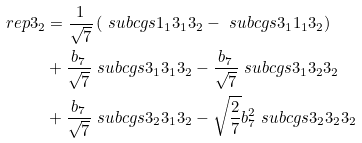<formula> <loc_0><loc_0><loc_500><loc_500>\ r e p { 3 } _ { 2 } & = \frac { 1 } { \sqrt { 7 } } \left ( \ s u b c g s { 1 _ { 1 } } { 3 _ { 1 } } { 3 _ { 2 } } - \ s u b c g s { 3 _ { 1 } } { 1 _ { 1 } } { 3 _ { 2 } } \right ) \\ & + \frac { b _ { 7 } } { \sqrt { 7 } } \ s u b c g s { 3 _ { 1 } } { 3 _ { 1 } } { 3 _ { 2 } } - \frac { b _ { 7 } } { \sqrt { 7 } } \ s u b c g s { 3 _ { 1 } } { 3 _ { 2 } } { 3 _ { 2 } } \\ & + \frac { b _ { 7 } } { \sqrt { 7 } } \ s u b c g s { 3 _ { 2 } } { 3 _ { 1 } } { 3 _ { 2 } } - \sqrt { \frac { 2 } { 7 } } b _ { 7 } ^ { 2 } \ s u b c g s { 3 _ { 2 } } { 3 _ { 2 } } { 3 _ { 2 } }</formula> 